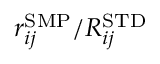Convert formula to latex. <formula><loc_0><loc_0><loc_500><loc_500>r _ { i j } ^ { S M P } / R _ { i j } ^ { S T D }</formula> 